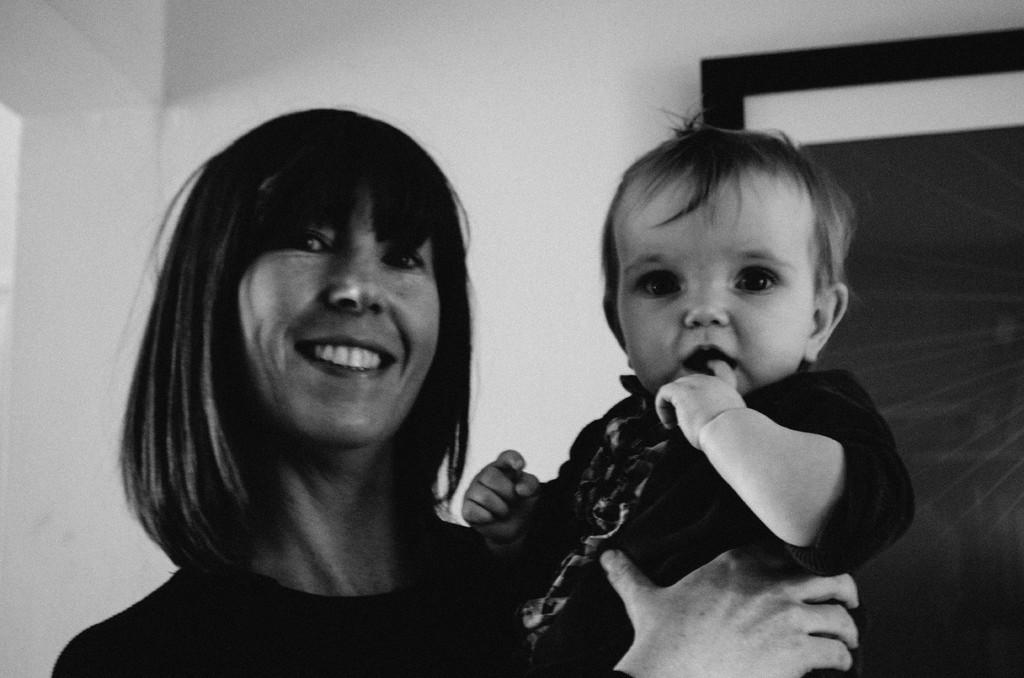What is the lady doing in the image? The lady is holding a baby in the image. What can be seen in the background of the image? There is a wall with an object in the background of the image. What is the color scheme of the image? The image is black and white. What type of dress is the baby wearing in the image? There is no dress visible in the image, as the baby is not wearing any clothing. 